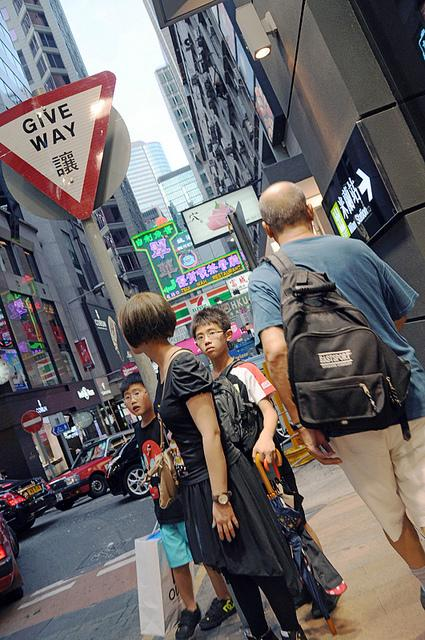The neon signs on the street are located in which city in Asia? hong kong 